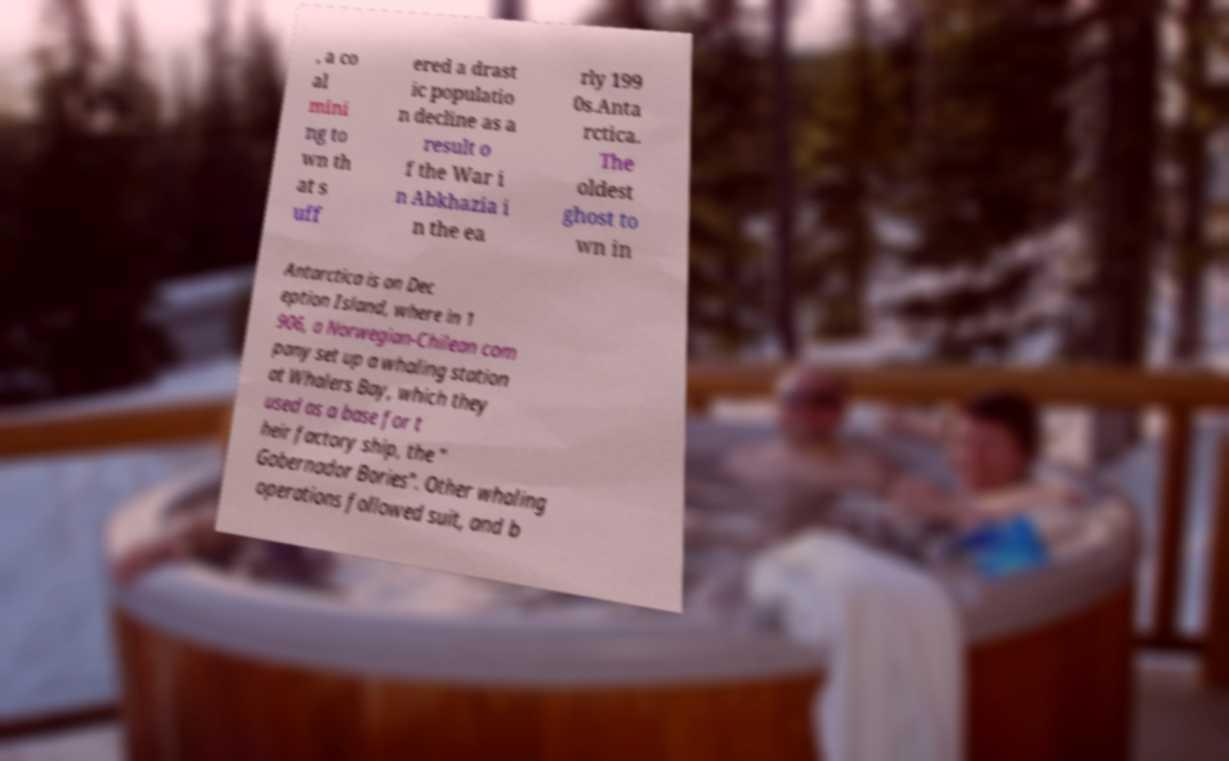There's text embedded in this image that I need extracted. Can you transcribe it verbatim? , a co al mini ng to wn th at s uff ered a drast ic populatio n decline as a result o f the War i n Abkhazia i n the ea rly 199 0s.Anta rctica. The oldest ghost to wn in Antarctica is on Dec eption Island, where in 1 906, a Norwegian-Chilean com pany set up a whaling station at Whalers Bay, which they used as a base for t heir factory ship, the " Gobernador Bories". Other whaling operations followed suit, and b 